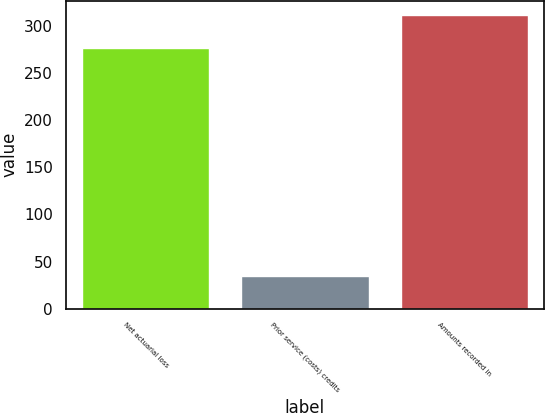Convert chart to OTSL. <chart><loc_0><loc_0><loc_500><loc_500><bar_chart><fcel>Net actuarial loss<fcel>Prior service (costs) credits<fcel>Amounts recorded in<nl><fcel>276.8<fcel>34.7<fcel>311.5<nl></chart> 